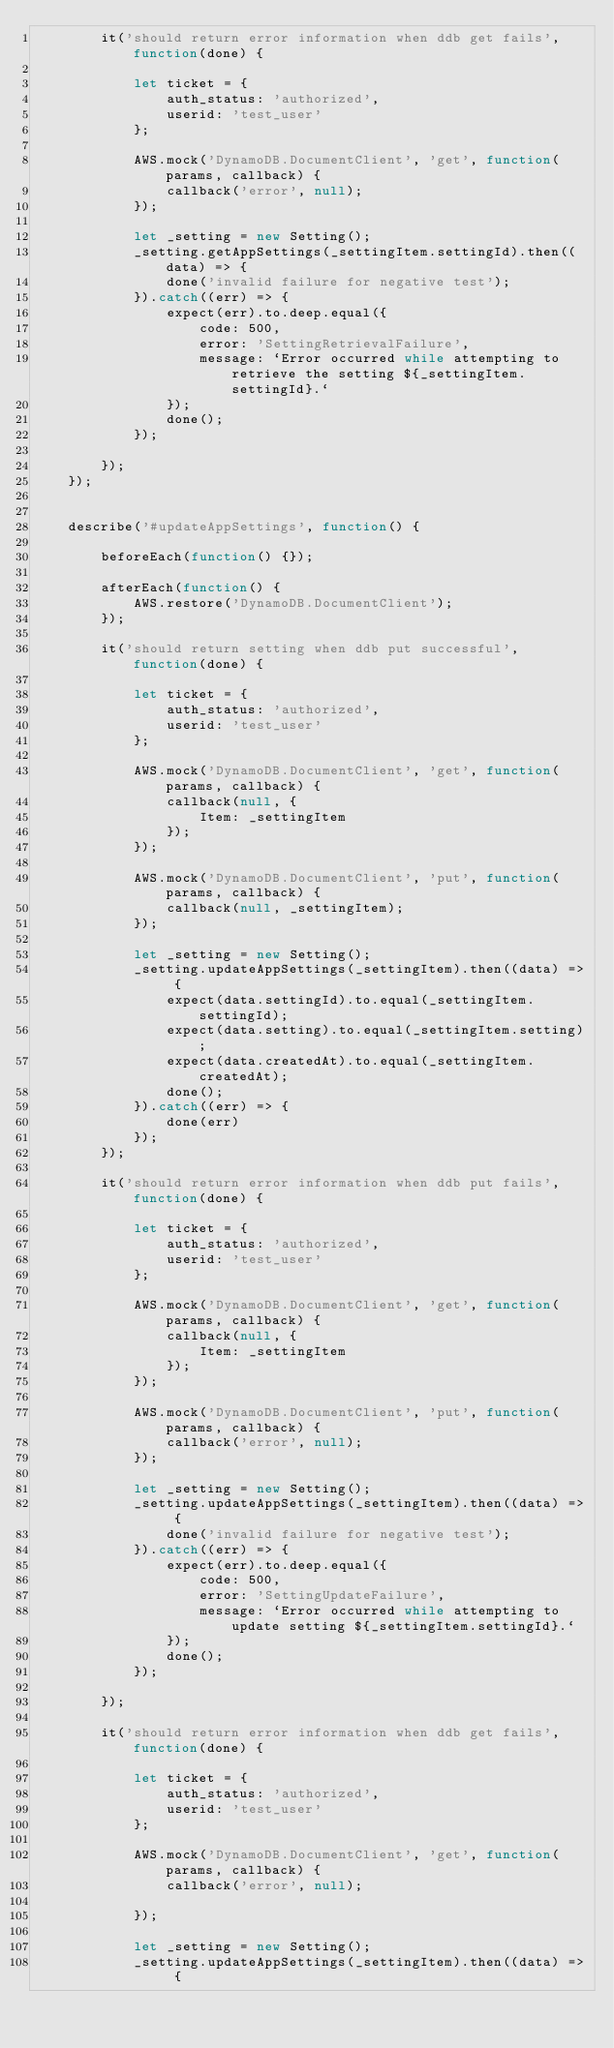<code> <loc_0><loc_0><loc_500><loc_500><_JavaScript_>        it('should return error information when ddb get fails', function(done) {

            let ticket = {
                auth_status: 'authorized',
                userid: 'test_user'
            };

            AWS.mock('DynamoDB.DocumentClient', 'get', function(params, callback) {
                callback('error', null);
            });

            let _setting = new Setting();
            _setting.getAppSettings(_settingItem.settingId).then((data) => {
                done('invalid failure for negative test');
            }).catch((err) => {
                expect(err).to.deep.equal({
                    code: 500,
                    error: 'SettingRetrievalFailure',
                    message: `Error occurred while attempting to retrieve the setting ${_settingItem.settingId}.`
                });
                done();
            });

        });
    });


    describe('#updateAppSettings', function() {

        beforeEach(function() {});

        afterEach(function() {
            AWS.restore('DynamoDB.DocumentClient');
        });

        it('should return setting when ddb put successful', function(done) {

            let ticket = {
                auth_status: 'authorized',
                userid: 'test_user'
            };

            AWS.mock('DynamoDB.DocumentClient', 'get', function(params, callback) {
                callback(null, {
                    Item: _settingItem
                });
            });

            AWS.mock('DynamoDB.DocumentClient', 'put', function(params, callback) {
                callback(null, _settingItem);
            });

            let _setting = new Setting();
            _setting.updateAppSettings(_settingItem).then((data) => {
                expect(data.settingId).to.equal(_settingItem.settingId);
                expect(data.setting).to.equal(_settingItem.setting);
                expect(data.createdAt).to.equal(_settingItem.createdAt);
                done();
            }).catch((err) => {
                done(err)
            });
        });

        it('should return error information when ddb put fails', function(done) {

            let ticket = {
                auth_status: 'authorized',
                userid: 'test_user'
            };

            AWS.mock('DynamoDB.DocumentClient', 'get', function(params, callback) {
                callback(null, {
                    Item: _settingItem
                });
            });

            AWS.mock('DynamoDB.DocumentClient', 'put', function(params, callback) {
                callback('error', null);
            });

            let _setting = new Setting();
            _setting.updateAppSettings(_settingItem).then((data) => {
                done('invalid failure for negative test');
            }).catch((err) => {
                expect(err).to.deep.equal({
                    code: 500,
                    error: 'SettingUpdateFailure',
                    message: `Error occurred while attempting to update setting ${_settingItem.settingId}.`
                });
                done();
            });

        });

        it('should return error information when ddb get fails', function(done) {

            let ticket = {
                auth_status: 'authorized',
                userid: 'test_user'
            };

            AWS.mock('DynamoDB.DocumentClient', 'get', function(params, callback) {
                callback('error', null);

            });

            let _setting = new Setting();
            _setting.updateAppSettings(_settingItem).then((data) => {</code> 